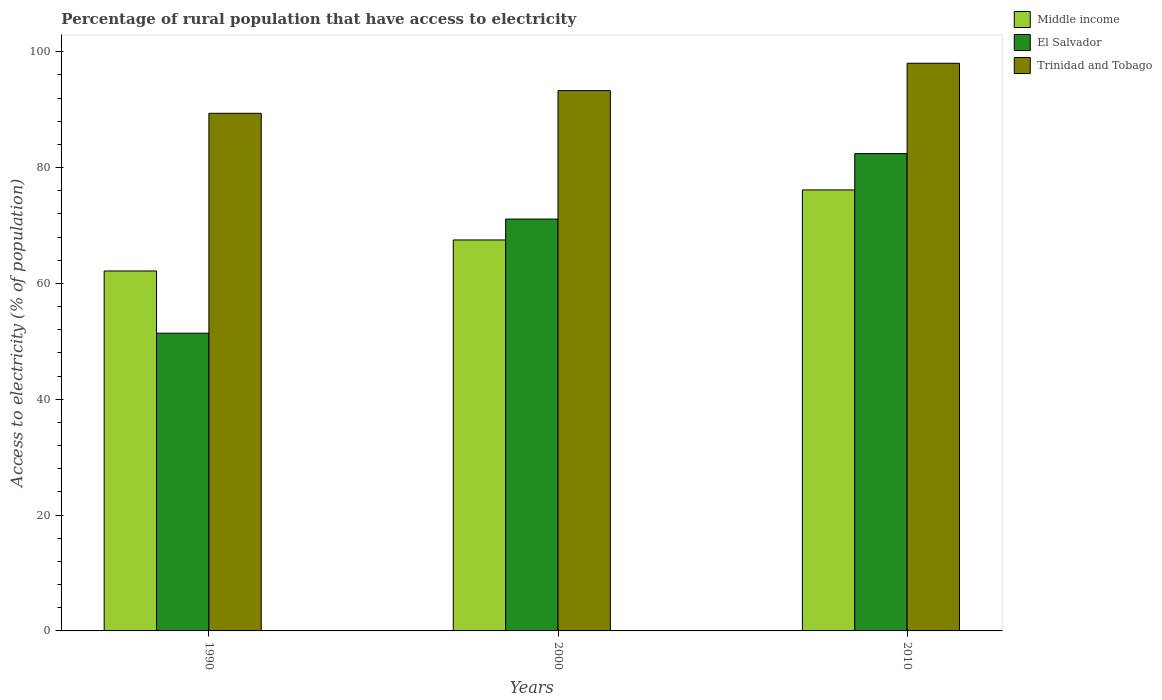Are the number of bars on each tick of the X-axis equal?
Offer a terse response. Yes. How many bars are there on the 3rd tick from the left?
Ensure brevity in your answer.  3. What is the percentage of rural population that have access to electricity in Trinidad and Tobago in 1990?
Make the answer very short. 89.36. Across all years, what is the maximum percentage of rural population that have access to electricity in Middle income?
Your answer should be compact. 76.13. Across all years, what is the minimum percentage of rural population that have access to electricity in Trinidad and Tobago?
Provide a succinct answer. 89.36. In which year was the percentage of rural population that have access to electricity in Middle income maximum?
Offer a very short reply. 2010. In which year was the percentage of rural population that have access to electricity in Middle income minimum?
Offer a terse response. 1990. What is the total percentage of rural population that have access to electricity in Middle income in the graph?
Offer a terse response. 205.77. What is the difference between the percentage of rural population that have access to electricity in El Salvador in 1990 and that in 2000?
Your answer should be very brief. -19.7. What is the difference between the percentage of rural population that have access to electricity in Trinidad and Tobago in 2010 and the percentage of rural population that have access to electricity in Middle income in 1990?
Keep it short and to the point. 35.86. What is the average percentage of rural population that have access to electricity in Middle income per year?
Your answer should be very brief. 68.59. In the year 2010, what is the difference between the percentage of rural population that have access to electricity in Trinidad and Tobago and percentage of rural population that have access to electricity in Middle income?
Your answer should be compact. 21.87. What is the ratio of the percentage of rural population that have access to electricity in Middle income in 2000 to that in 2010?
Offer a terse response. 0.89. Is the percentage of rural population that have access to electricity in Trinidad and Tobago in 1990 less than that in 2000?
Make the answer very short. Yes. Is the difference between the percentage of rural population that have access to electricity in Trinidad and Tobago in 2000 and 2010 greater than the difference between the percentage of rural population that have access to electricity in Middle income in 2000 and 2010?
Offer a terse response. Yes. What is the difference between the highest and the second highest percentage of rural population that have access to electricity in Middle income?
Offer a terse response. 8.63. What is the difference between the highest and the lowest percentage of rural population that have access to electricity in El Salvador?
Offer a very short reply. 31. In how many years, is the percentage of rural population that have access to electricity in Trinidad and Tobago greater than the average percentage of rural population that have access to electricity in Trinidad and Tobago taken over all years?
Provide a short and direct response. 1. Is the sum of the percentage of rural population that have access to electricity in Trinidad and Tobago in 1990 and 2000 greater than the maximum percentage of rural population that have access to electricity in Middle income across all years?
Give a very brief answer. Yes. What does the 2nd bar from the left in 1990 represents?
Your answer should be compact. El Salvador. Is it the case that in every year, the sum of the percentage of rural population that have access to electricity in El Salvador and percentage of rural population that have access to electricity in Trinidad and Tobago is greater than the percentage of rural population that have access to electricity in Middle income?
Your response must be concise. Yes. Are all the bars in the graph horizontal?
Your answer should be very brief. No. How many years are there in the graph?
Keep it short and to the point. 3. What is the difference between two consecutive major ticks on the Y-axis?
Ensure brevity in your answer.  20. Does the graph contain grids?
Keep it short and to the point. No. How are the legend labels stacked?
Give a very brief answer. Vertical. What is the title of the graph?
Provide a short and direct response. Percentage of rural population that have access to electricity. What is the label or title of the Y-axis?
Your answer should be very brief. Access to electricity (% of population). What is the Access to electricity (% of population) in Middle income in 1990?
Your answer should be very brief. 62.14. What is the Access to electricity (% of population) of El Salvador in 1990?
Your response must be concise. 51.4. What is the Access to electricity (% of population) of Trinidad and Tobago in 1990?
Keep it short and to the point. 89.36. What is the Access to electricity (% of population) of Middle income in 2000?
Your answer should be compact. 67.5. What is the Access to electricity (% of population) of El Salvador in 2000?
Your answer should be very brief. 71.1. What is the Access to electricity (% of population) in Trinidad and Tobago in 2000?
Offer a very short reply. 93.28. What is the Access to electricity (% of population) of Middle income in 2010?
Provide a succinct answer. 76.13. What is the Access to electricity (% of population) of El Salvador in 2010?
Your answer should be very brief. 82.4. Across all years, what is the maximum Access to electricity (% of population) in Middle income?
Offer a very short reply. 76.13. Across all years, what is the maximum Access to electricity (% of population) of El Salvador?
Ensure brevity in your answer.  82.4. Across all years, what is the minimum Access to electricity (% of population) in Middle income?
Provide a succinct answer. 62.14. Across all years, what is the minimum Access to electricity (% of population) of El Salvador?
Make the answer very short. 51.4. Across all years, what is the minimum Access to electricity (% of population) of Trinidad and Tobago?
Ensure brevity in your answer.  89.36. What is the total Access to electricity (% of population) of Middle income in the graph?
Your answer should be compact. 205.77. What is the total Access to electricity (% of population) in El Salvador in the graph?
Your answer should be compact. 204.9. What is the total Access to electricity (% of population) of Trinidad and Tobago in the graph?
Your answer should be very brief. 280.64. What is the difference between the Access to electricity (% of population) of Middle income in 1990 and that in 2000?
Provide a succinct answer. -5.36. What is the difference between the Access to electricity (% of population) in El Salvador in 1990 and that in 2000?
Offer a very short reply. -19.7. What is the difference between the Access to electricity (% of population) in Trinidad and Tobago in 1990 and that in 2000?
Ensure brevity in your answer.  -3.92. What is the difference between the Access to electricity (% of population) of Middle income in 1990 and that in 2010?
Make the answer very short. -13.99. What is the difference between the Access to electricity (% of population) in El Salvador in 1990 and that in 2010?
Offer a terse response. -31. What is the difference between the Access to electricity (% of population) in Trinidad and Tobago in 1990 and that in 2010?
Make the answer very short. -8.64. What is the difference between the Access to electricity (% of population) in Middle income in 2000 and that in 2010?
Provide a succinct answer. -8.63. What is the difference between the Access to electricity (% of population) of Trinidad and Tobago in 2000 and that in 2010?
Your answer should be compact. -4.72. What is the difference between the Access to electricity (% of population) of Middle income in 1990 and the Access to electricity (% of population) of El Salvador in 2000?
Make the answer very short. -8.96. What is the difference between the Access to electricity (% of population) in Middle income in 1990 and the Access to electricity (% of population) in Trinidad and Tobago in 2000?
Your answer should be compact. -31.14. What is the difference between the Access to electricity (% of population) in El Salvador in 1990 and the Access to electricity (% of population) in Trinidad and Tobago in 2000?
Offer a terse response. -41.88. What is the difference between the Access to electricity (% of population) in Middle income in 1990 and the Access to electricity (% of population) in El Salvador in 2010?
Provide a short and direct response. -20.26. What is the difference between the Access to electricity (% of population) of Middle income in 1990 and the Access to electricity (% of population) of Trinidad and Tobago in 2010?
Give a very brief answer. -35.86. What is the difference between the Access to electricity (% of population) in El Salvador in 1990 and the Access to electricity (% of population) in Trinidad and Tobago in 2010?
Give a very brief answer. -46.6. What is the difference between the Access to electricity (% of population) of Middle income in 2000 and the Access to electricity (% of population) of El Salvador in 2010?
Offer a terse response. -14.9. What is the difference between the Access to electricity (% of population) in Middle income in 2000 and the Access to electricity (% of population) in Trinidad and Tobago in 2010?
Provide a succinct answer. -30.5. What is the difference between the Access to electricity (% of population) of El Salvador in 2000 and the Access to electricity (% of population) of Trinidad and Tobago in 2010?
Keep it short and to the point. -26.9. What is the average Access to electricity (% of population) of Middle income per year?
Offer a terse response. 68.59. What is the average Access to electricity (% of population) of El Salvador per year?
Offer a very short reply. 68.3. What is the average Access to electricity (% of population) of Trinidad and Tobago per year?
Ensure brevity in your answer.  93.55. In the year 1990, what is the difference between the Access to electricity (% of population) of Middle income and Access to electricity (% of population) of El Salvador?
Provide a short and direct response. 10.74. In the year 1990, what is the difference between the Access to electricity (% of population) of Middle income and Access to electricity (% of population) of Trinidad and Tobago?
Make the answer very short. -27.22. In the year 1990, what is the difference between the Access to electricity (% of population) of El Salvador and Access to electricity (% of population) of Trinidad and Tobago?
Your answer should be compact. -37.96. In the year 2000, what is the difference between the Access to electricity (% of population) in Middle income and Access to electricity (% of population) in El Salvador?
Your response must be concise. -3.6. In the year 2000, what is the difference between the Access to electricity (% of population) of Middle income and Access to electricity (% of population) of Trinidad and Tobago?
Provide a succinct answer. -25.78. In the year 2000, what is the difference between the Access to electricity (% of population) in El Salvador and Access to electricity (% of population) in Trinidad and Tobago?
Provide a short and direct response. -22.18. In the year 2010, what is the difference between the Access to electricity (% of population) of Middle income and Access to electricity (% of population) of El Salvador?
Provide a succinct answer. -6.27. In the year 2010, what is the difference between the Access to electricity (% of population) of Middle income and Access to electricity (% of population) of Trinidad and Tobago?
Offer a terse response. -21.87. In the year 2010, what is the difference between the Access to electricity (% of population) in El Salvador and Access to electricity (% of population) in Trinidad and Tobago?
Keep it short and to the point. -15.6. What is the ratio of the Access to electricity (% of population) in Middle income in 1990 to that in 2000?
Offer a very short reply. 0.92. What is the ratio of the Access to electricity (% of population) of El Salvador in 1990 to that in 2000?
Keep it short and to the point. 0.72. What is the ratio of the Access to electricity (% of population) in Trinidad and Tobago in 1990 to that in 2000?
Give a very brief answer. 0.96. What is the ratio of the Access to electricity (% of population) in Middle income in 1990 to that in 2010?
Provide a short and direct response. 0.82. What is the ratio of the Access to electricity (% of population) of El Salvador in 1990 to that in 2010?
Offer a very short reply. 0.62. What is the ratio of the Access to electricity (% of population) of Trinidad and Tobago in 1990 to that in 2010?
Offer a terse response. 0.91. What is the ratio of the Access to electricity (% of population) of Middle income in 2000 to that in 2010?
Make the answer very short. 0.89. What is the ratio of the Access to electricity (% of population) in El Salvador in 2000 to that in 2010?
Ensure brevity in your answer.  0.86. What is the ratio of the Access to electricity (% of population) in Trinidad and Tobago in 2000 to that in 2010?
Give a very brief answer. 0.95. What is the difference between the highest and the second highest Access to electricity (% of population) of Middle income?
Your answer should be very brief. 8.63. What is the difference between the highest and the second highest Access to electricity (% of population) in Trinidad and Tobago?
Offer a very short reply. 4.72. What is the difference between the highest and the lowest Access to electricity (% of population) in Middle income?
Keep it short and to the point. 13.99. What is the difference between the highest and the lowest Access to electricity (% of population) in El Salvador?
Your response must be concise. 31. What is the difference between the highest and the lowest Access to electricity (% of population) in Trinidad and Tobago?
Provide a succinct answer. 8.64. 